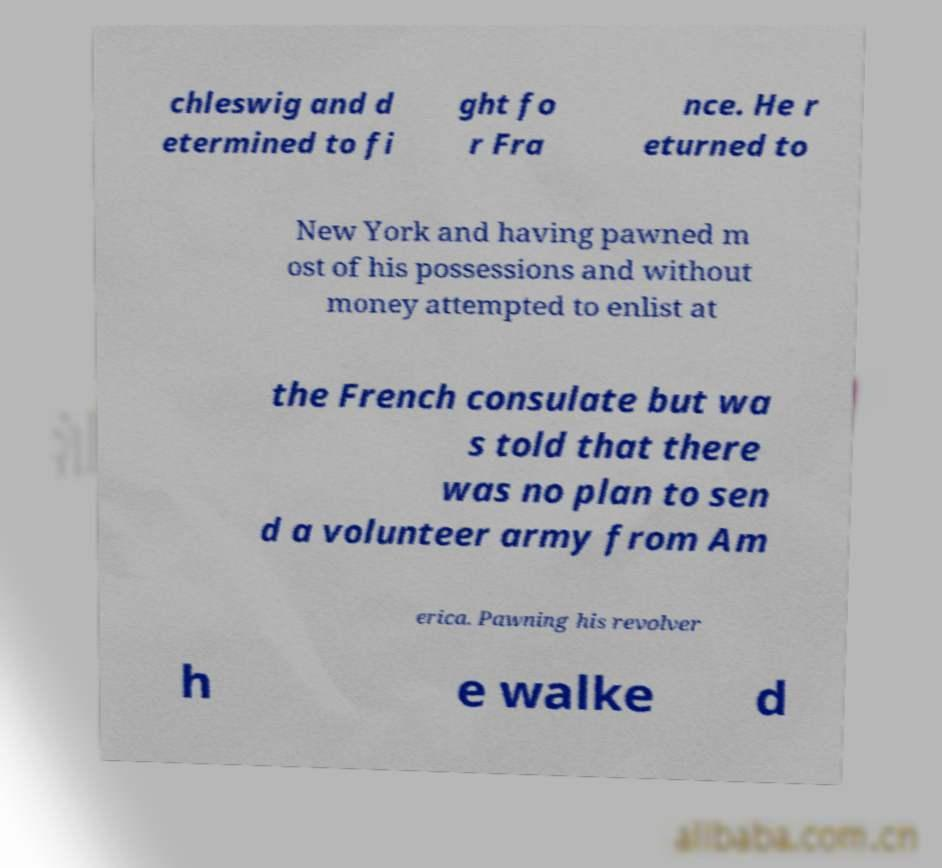Could you extract and type out the text from this image? chleswig and d etermined to fi ght fo r Fra nce. He r eturned to New York and having pawned m ost of his possessions and without money attempted to enlist at the French consulate but wa s told that there was no plan to sen d a volunteer army from Am erica. Pawning his revolver h e walke d 